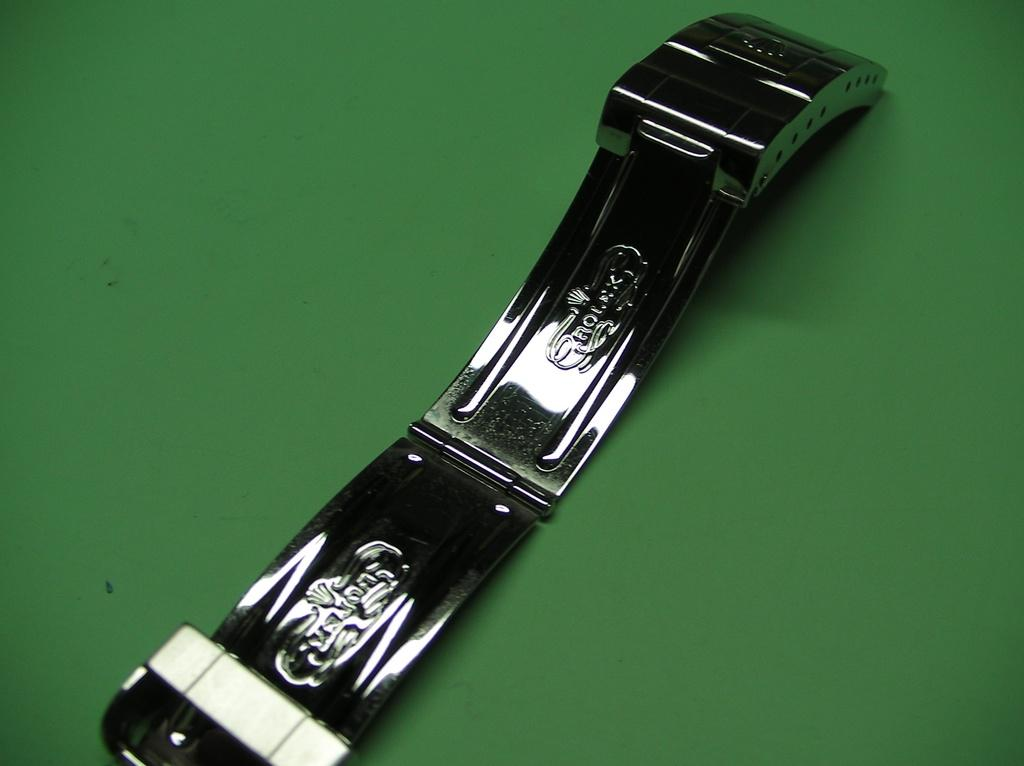What type of object is present in the image? There is a metal object in the image. Where is the metal object located? The metal object is on a surface. What color is the metal object? The metal object is green in color. Is there any text on the metal object? Yes, there is text carved on the metal object. Is there a volcano erupting in the background of the image? There is no volcano or any background visible in the image; it only features a green metal object on a surface with text carved on it. 